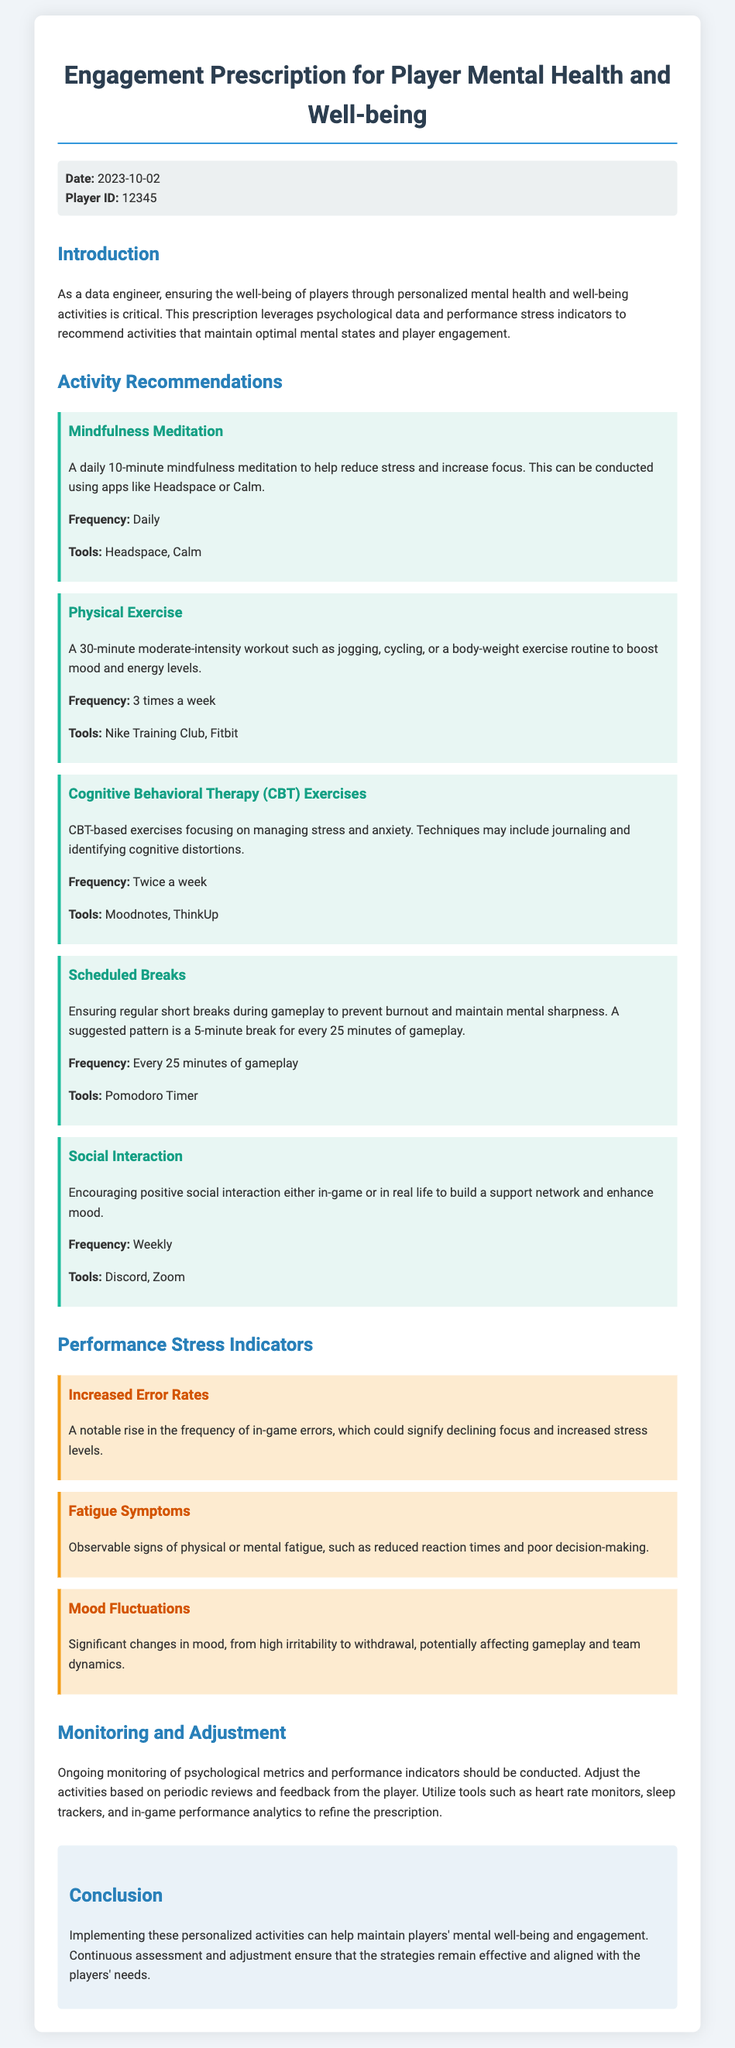What is the date of the prescription? The date listed in the document is provided in the meta-info section.
Answer: 2023-10-02 What is the Player ID? The Player ID is specified in the meta-info section of the document.
Answer: 12345 How often should mindfulness meditation be conducted? The frequency of mindfulness meditation is mentioned under the activity recommendations section.
Answer: Daily What is one tool suggested for physical exercise? The tools for physical exercise are outlined in the activity recommendations section.
Answer: Nike Training Club What performance stress indicator relates to signs of fatigue? The stress indicators section describes various symptoms, one of which pertains to fatigue.
Answer: Fatigue Symptoms How many times a week are CBT exercises suggested? The frequency of CBT exercises is detailed in the activity recommendations section.
Answer: Twice a week What should players do every 25 minutes of gameplay? The document specifies an activity that players should partake in at this interval.
Answer: Scheduled Breaks What is the main purpose of ongoing monitoring mentioned? The purpose of ongoing monitoring is discussed in the monitoring and adjustment section of the document.
Answer: To refine the prescription Which activity encourages positive social interaction? The activity that promotes social interaction is detailed in the activity recommendations.
Answer: Social Interaction 